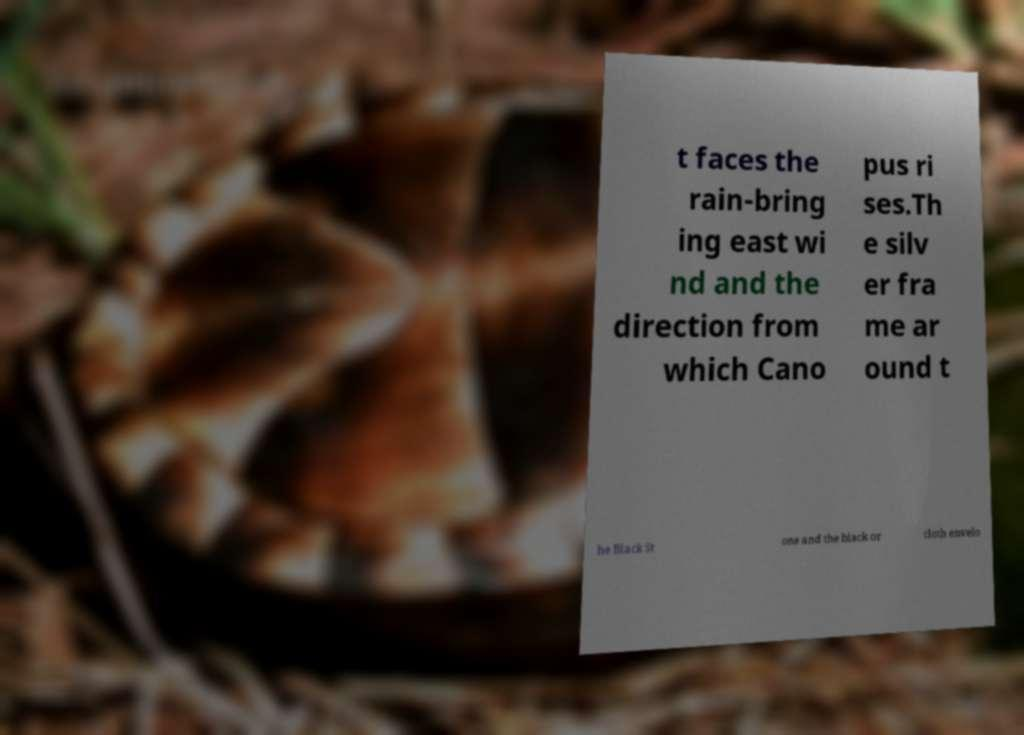Could you assist in decoding the text presented in this image and type it out clearly? t faces the rain-bring ing east wi nd and the direction from which Cano pus ri ses.Th e silv er fra me ar ound t he Black St one and the black or cloth envelo 